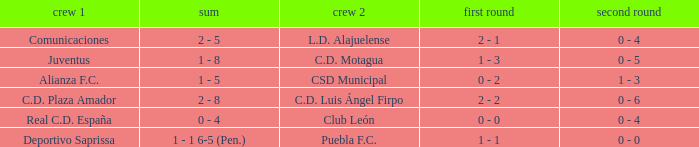What is the 1st leg where Team 1 is C.D. Plaza Amador? 2 - 2. 